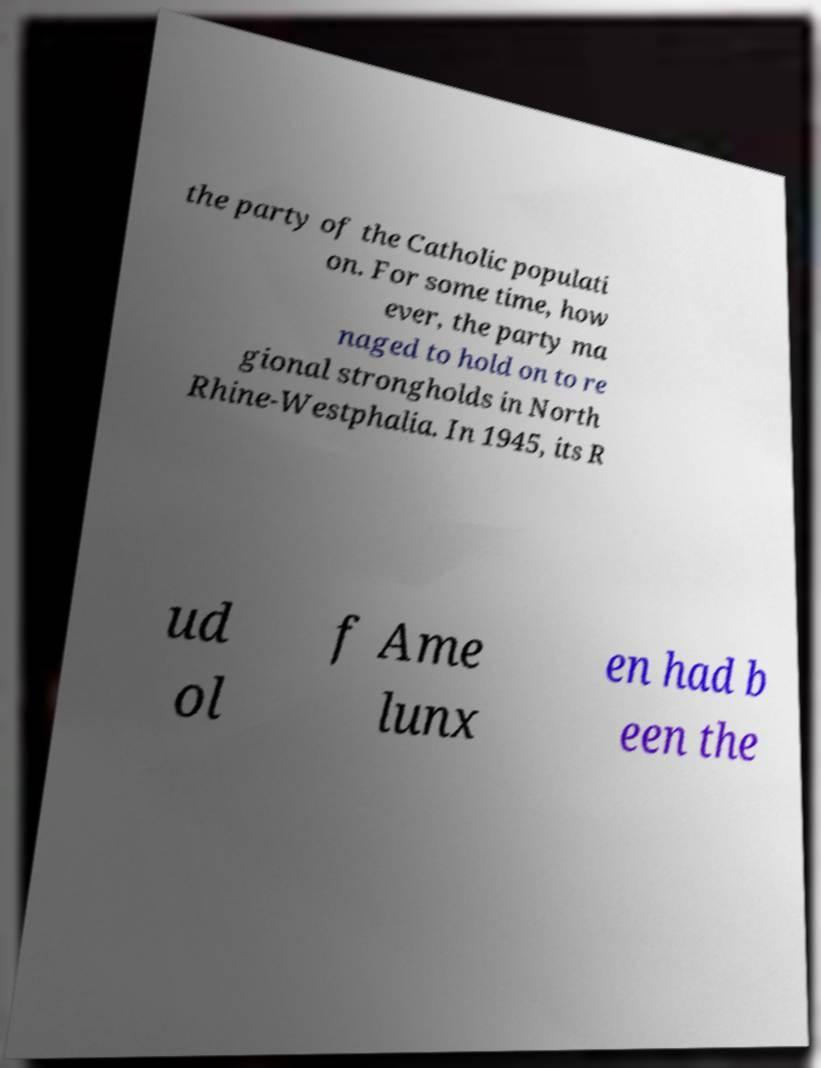Could you assist in decoding the text presented in this image and type it out clearly? the party of the Catholic populati on. For some time, how ever, the party ma naged to hold on to re gional strongholds in North Rhine-Westphalia. In 1945, its R ud ol f Ame lunx en had b een the 